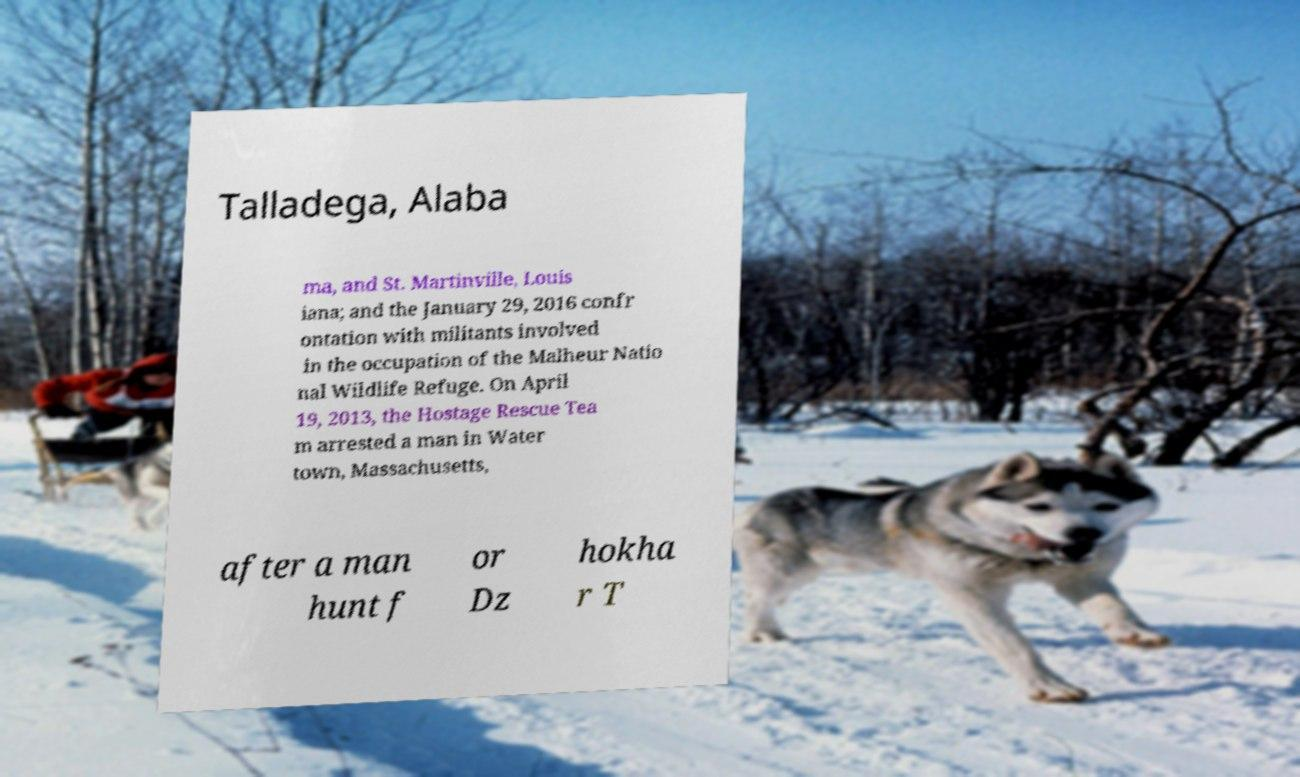For documentation purposes, I need the text within this image transcribed. Could you provide that? Talladega, Alaba ma, and St. Martinville, Louis iana; and the January 29, 2016 confr ontation with militants involved in the occupation of the Malheur Natio nal Wildlife Refuge. On April 19, 2013, the Hostage Rescue Tea m arrested a man in Water town, Massachusetts, after a man hunt f or Dz hokha r T 